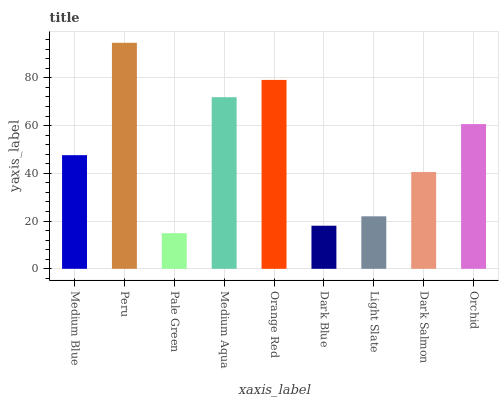Is Peru the minimum?
Answer yes or no. No. Is Pale Green the maximum?
Answer yes or no. No. Is Peru greater than Pale Green?
Answer yes or no. Yes. Is Pale Green less than Peru?
Answer yes or no. Yes. Is Pale Green greater than Peru?
Answer yes or no. No. Is Peru less than Pale Green?
Answer yes or no. No. Is Medium Blue the high median?
Answer yes or no. Yes. Is Medium Blue the low median?
Answer yes or no. Yes. Is Dark Blue the high median?
Answer yes or no. No. Is Medium Aqua the low median?
Answer yes or no. No. 